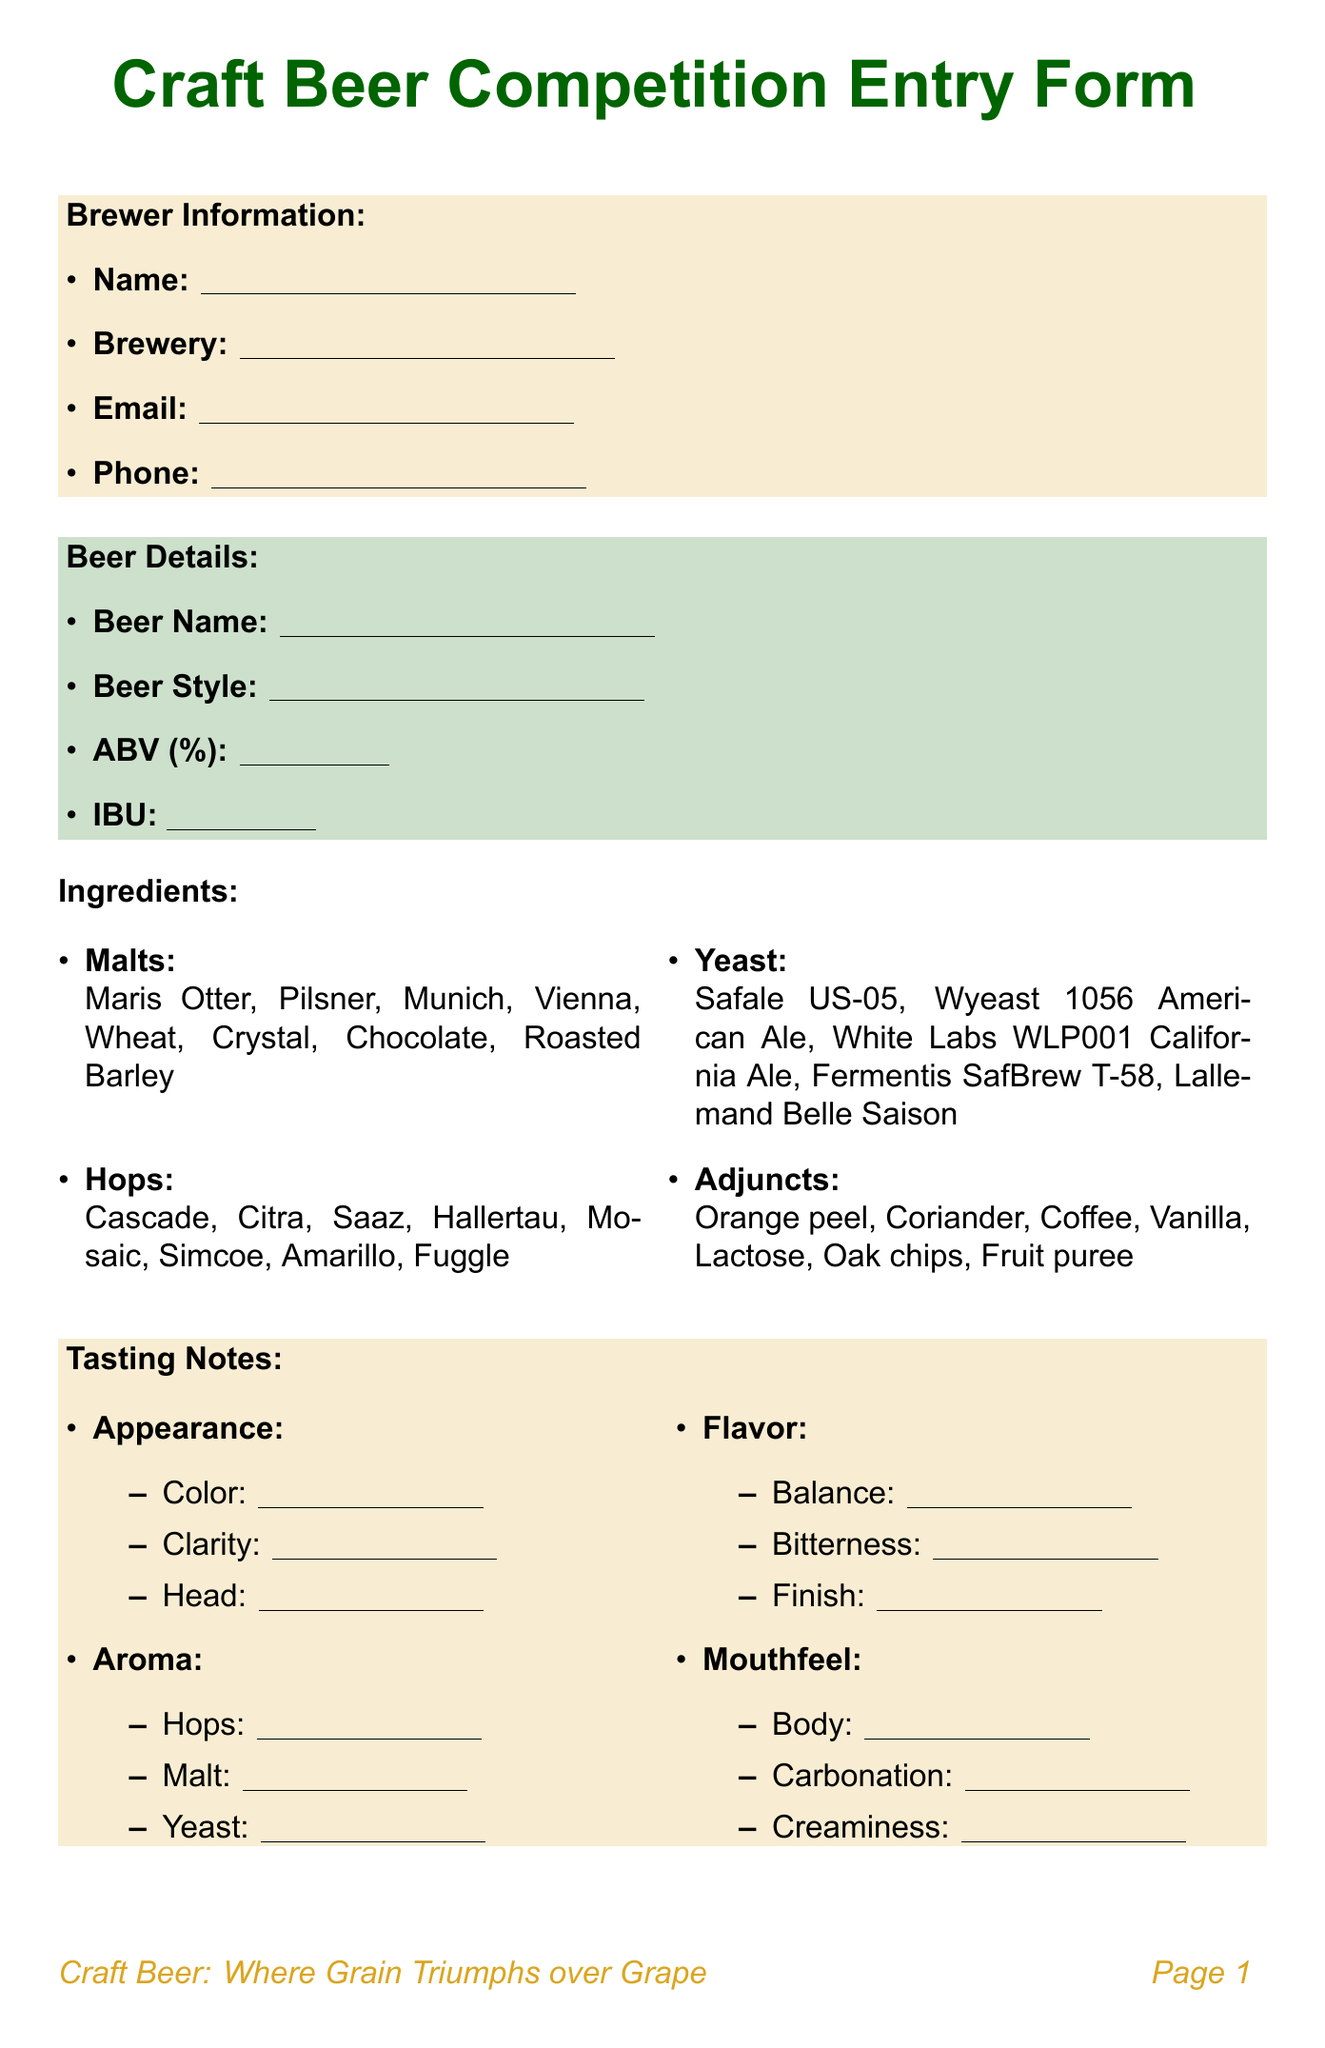What is the title of the document? The title of the document is given at the start of the entry form.
Answer: Craft Beer Competition Entry Form What are the first and last names of the brewer? The document label indicates where the brewers can fill in their name.
Answer: Full Name Which beer style options are provided? The beer styles are listed in a specific section called "Beer Details" in the document.
Answer: American IPA, Belgian Tripel, German Hefeweizen, English Bitter, Russian Imperial Stout, American Pale Ale, Saison, Berliner Weisse, Flanders Red Ale, New England IPA What is the highest IBU value defined in the form? The form allows the input of IBU, referencing the information in the beer details section.
Answer: IBU What are two fermentation temperature options? The brewing process section provides specifics where fermentation temp is mentioned.
Answer: Fermentation Temperature (°F) Which category is focused on local ingredients? The competition categories listed provide various specific options for categorization.
Answer: Best Use of Local Ingredients What are the craft beer strengths mentioned? The grape vs. grain debate section lists several strengths related to craft beer.
Answer: Diverse flavor profiles, Experimental ingredient combinations, Local and seasonal variations, Broader range of styles Is dry hopping included as an option in the brewing process? The brewing process section explicitly asks for yes or no regarding dry hopping.
Answer: yes/no What is the appearance option for clarity? Under the tasting notes section, clarity is listed as part of the appearance details.
Answer: Brilliant, Clear, Slight haze, Hazy, Opaque 